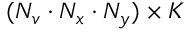<formula> <loc_0><loc_0><loc_500><loc_500>{ ( N _ { v } \cdot N _ { x } \cdot N _ { y } ) \times K }</formula> 